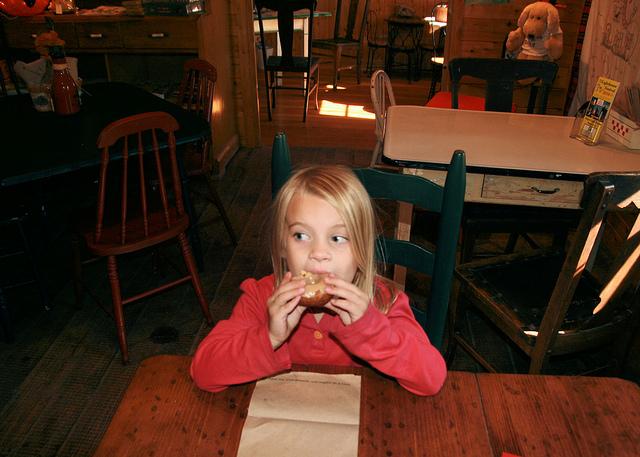What color is the child's hair?
Concise answer only. Blonde. Is the girl in a restaurant?
Short answer required. Yes. Is she using a plate?
Give a very brief answer. No. 